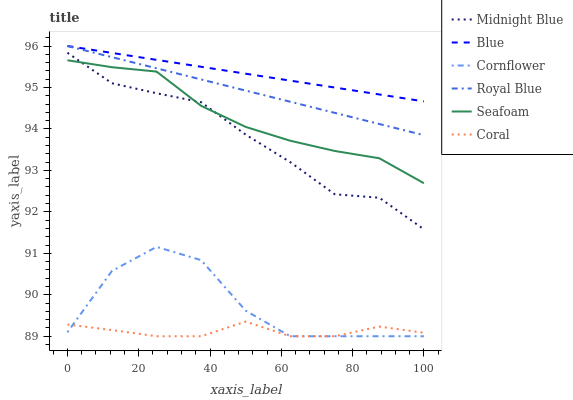Does Coral have the minimum area under the curve?
Answer yes or no. Yes. Does Blue have the maximum area under the curve?
Answer yes or no. Yes. Does Cornflower have the minimum area under the curve?
Answer yes or no. No. Does Cornflower have the maximum area under the curve?
Answer yes or no. No. Is Royal Blue the smoothest?
Answer yes or no. Yes. Is Cornflower the roughest?
Answer yes or no. Yes. Is Midnight Blue the smoothest?
Answer yes or no. No. Is Midnight Blue the roughest?
Answer yes or no. No. Does Cornflower have the lowest value?
Answer yes or no. Yes. Does Midnight Blue have the lowest value?
Answer yes or no. No. Does Royal Blue have the highest value?
Answer yes or no. Yes. Does Cornflower have the highest value?
Answer yes or no. No. Is Coral less than Blue?
Answer yes or no. Yes. Is Midnight Blue greater than Coral?
Answer yes or no. Yes. Does Midnight Blue intersect Seafoam?
Answer yes or no. Yes. Is Midnight Blue less than Seafoam?
Answer yes or no. No. Is Midnight Blue greater than Seafoam?
Answer yes or no. No. Does Coral intersect Blue?
Answer yes or no. No. 